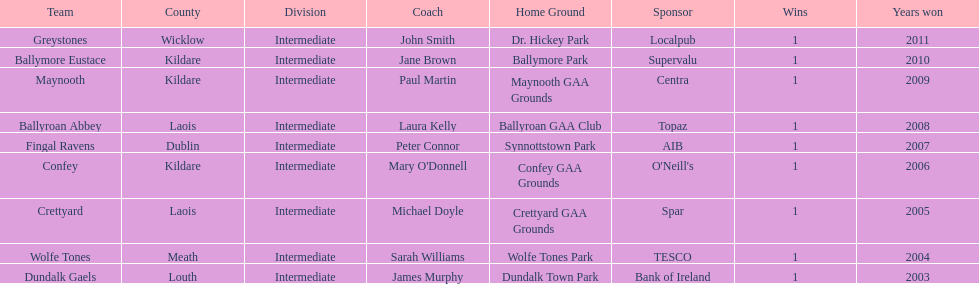Ballymore eustace is from the same county as what team that won in 2009? Maynooth. 